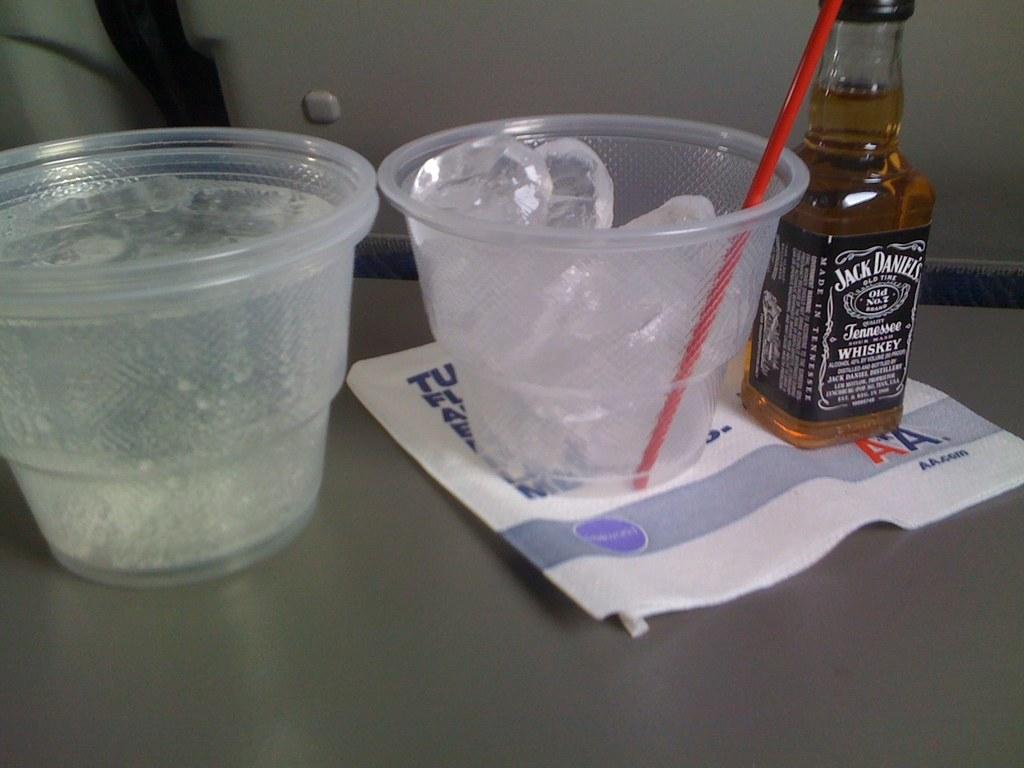What objects in the image contain ice cubes? There are two glasses with ice cubes in the image. What other beverage-related object can be seen in the image? There is a bottle in the image. What type of insurance policy is being discussed in the image? There is no mention of insurance in the image; it only contains two glasses with ice cubes and a bottle. 